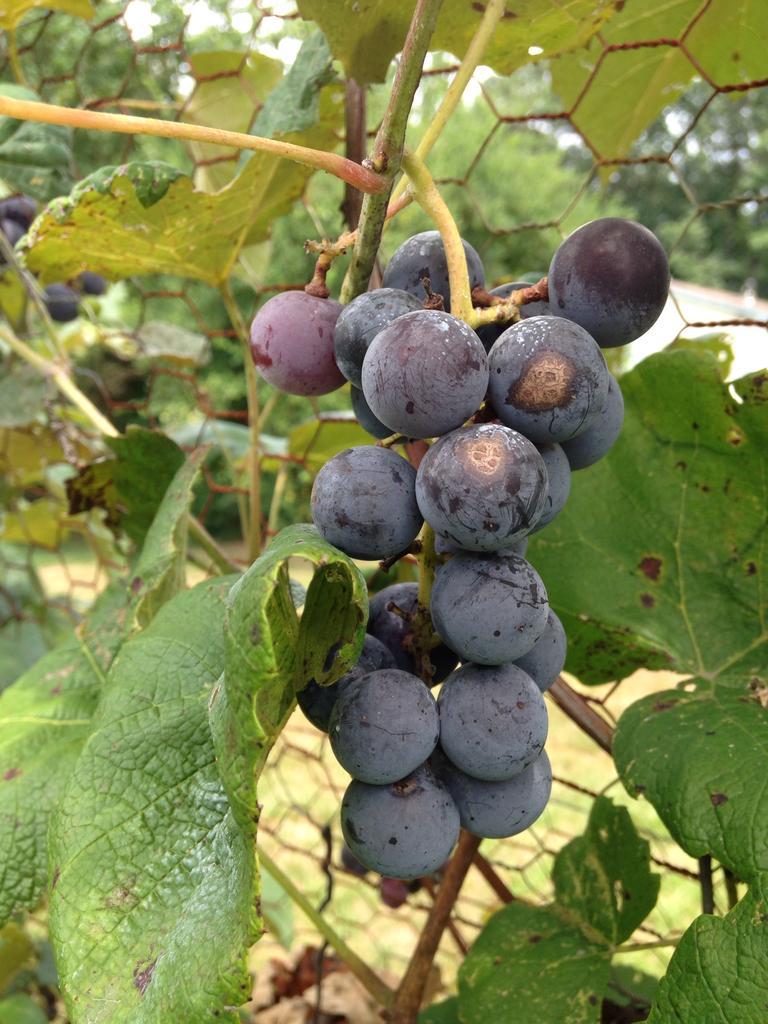In one or two sentences, can you explain what this image depicts? In this picture I can see the grape tree. I can see the metal grill fence. 